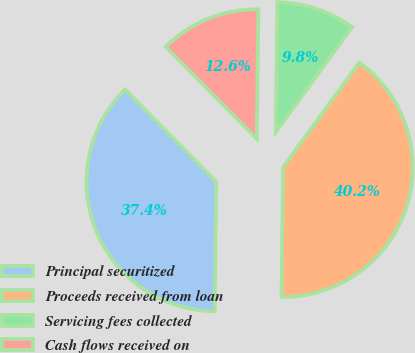Convert chart to OTSL. <chart><loc_0><loc_0><loc_500><loc_500><pie_chart><fcel>Principal securitized<fcel>Proceeds received from loan<fcel>Servicing fees collected<fcel>Cash flows received on<nl><fcel>37.4%<fcel>40.18%<fcel>9.82%<fcel>12.6%<nl></chart> 